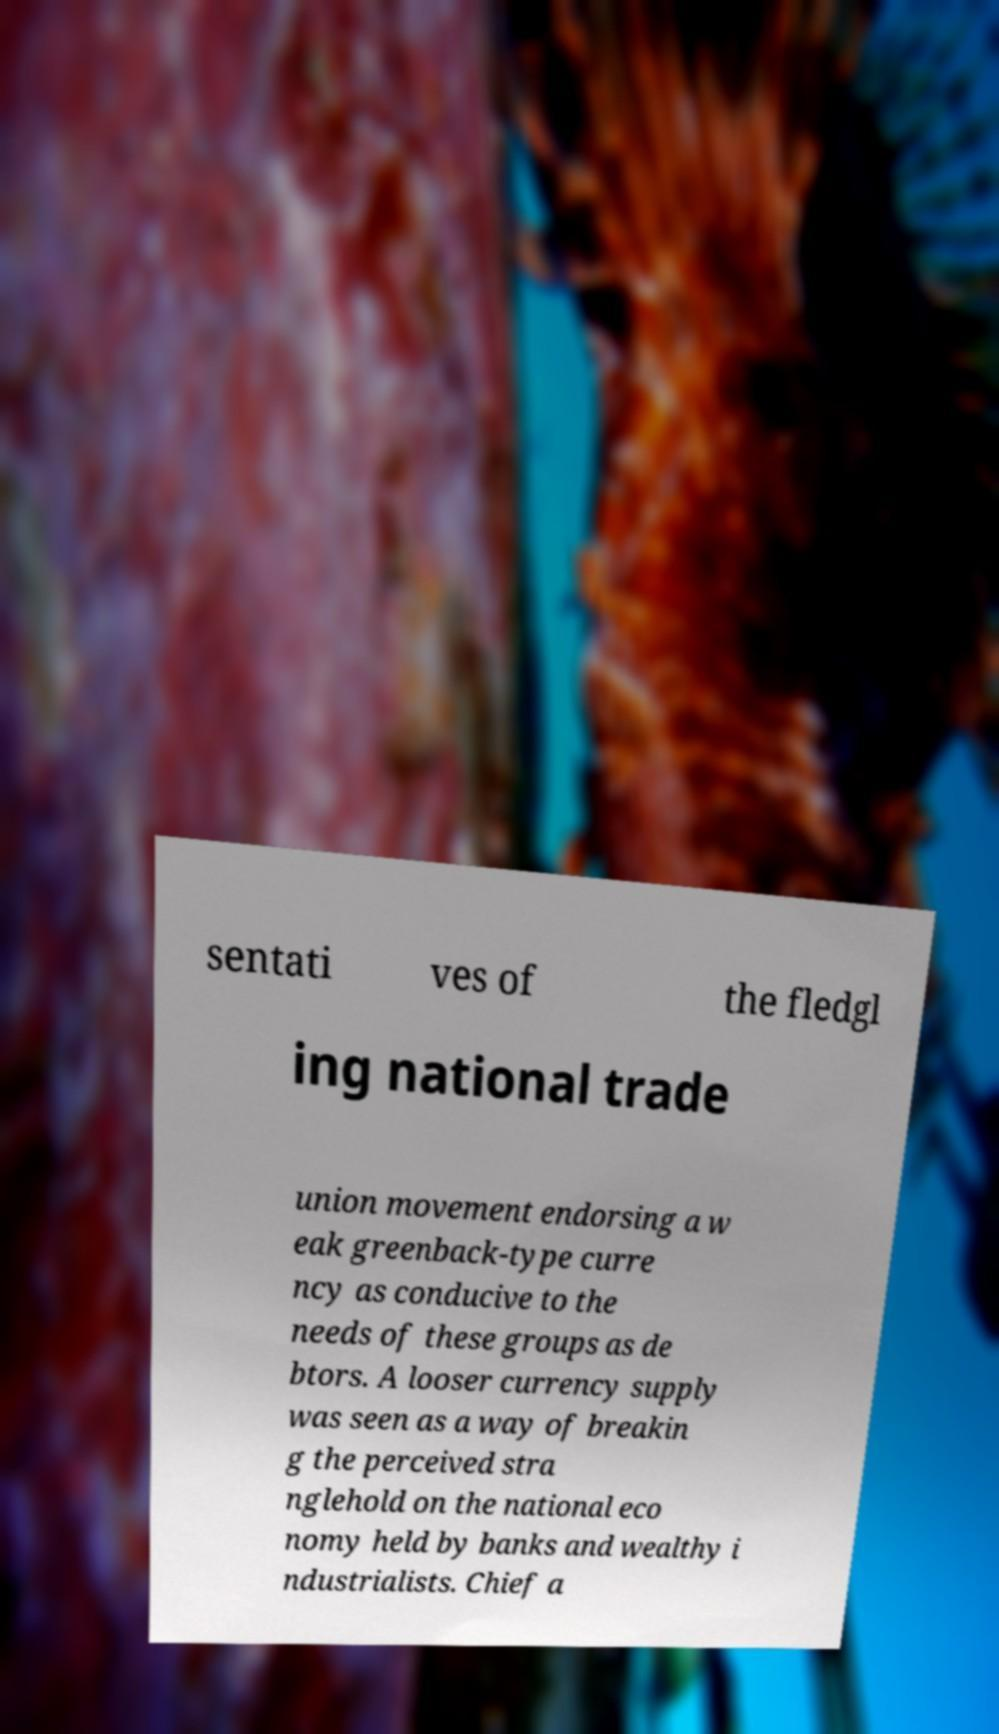Can you read and provide the text displayed in the image?This photo seems to have some interesting text. Can you extract and type it out for me? sentati ves of the fledgl ing national trade union movement endorsing a w eak greenback-type curre ncy as conducive to the needs of these groups as de btors. A looser currency supply was seen as a way of breakin g the perceived stra nglehold on the national eco nomy held by banks and wealthy i ndustrialists. Chief a 